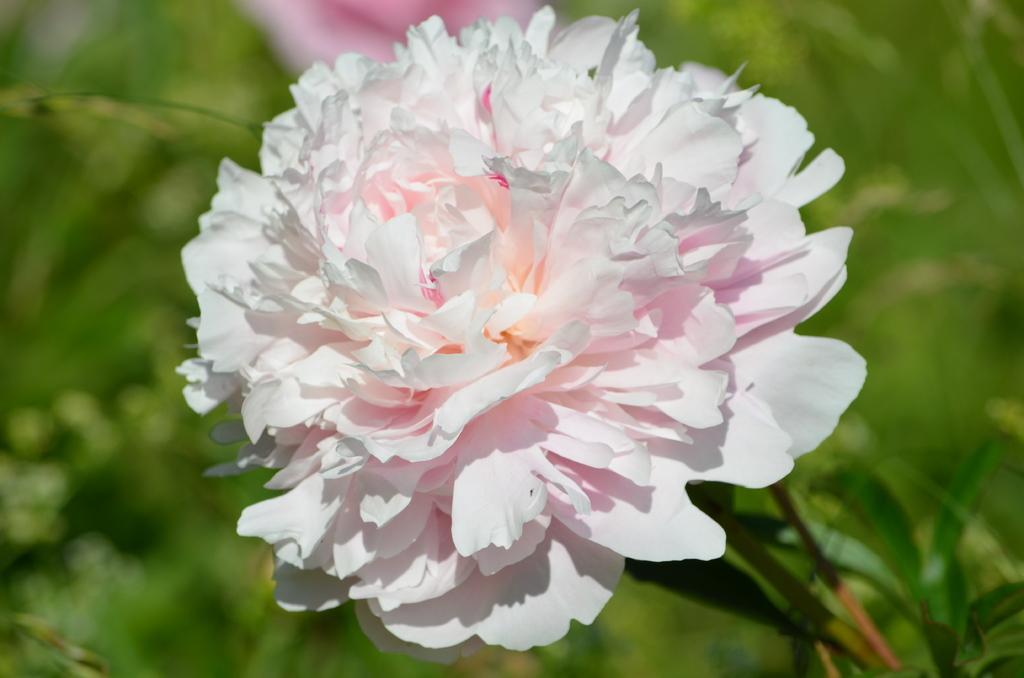Please provide a concise description of this image. There is a flower in the center of the image. 